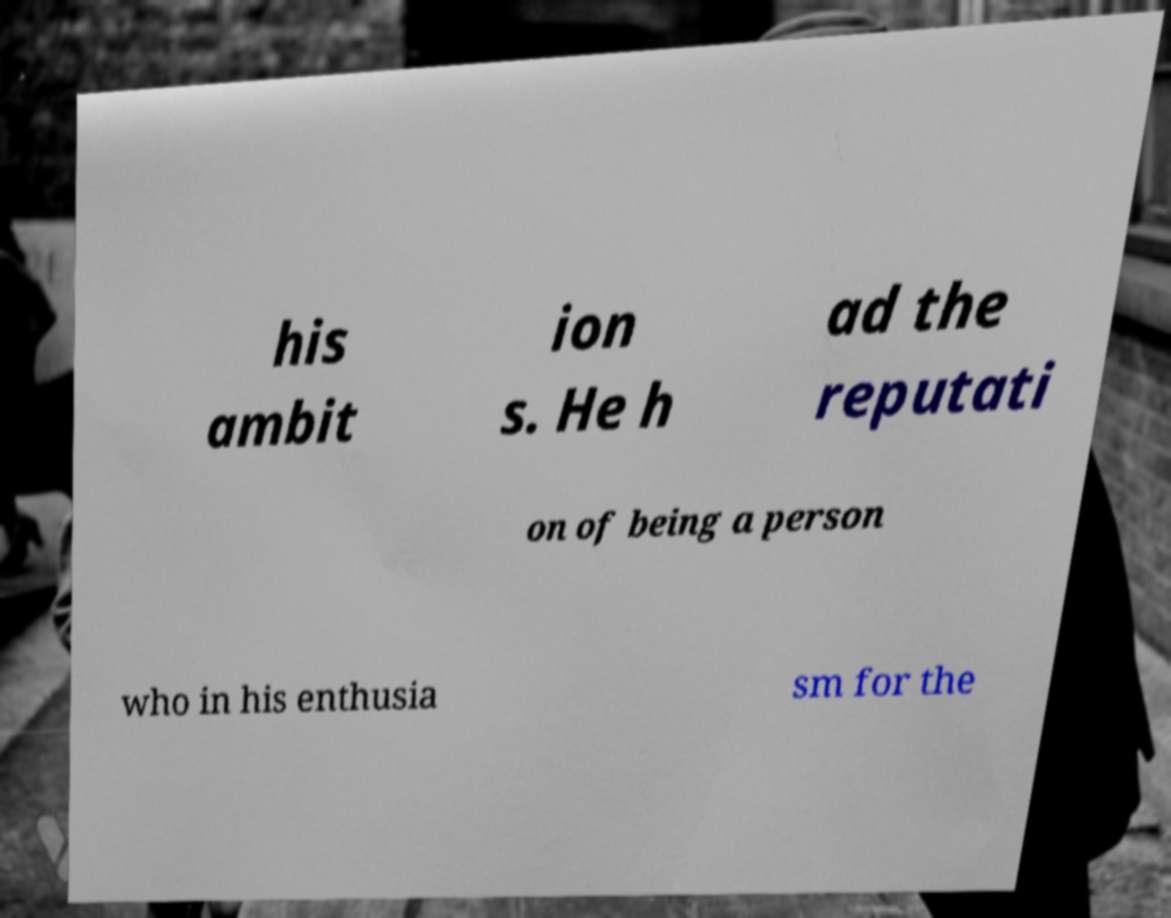What messages or text are displayed in this image? I need them in a readable, typed format. his ambit ion s. He h ad the reputati on of being a person who in his enthusia sm for the 